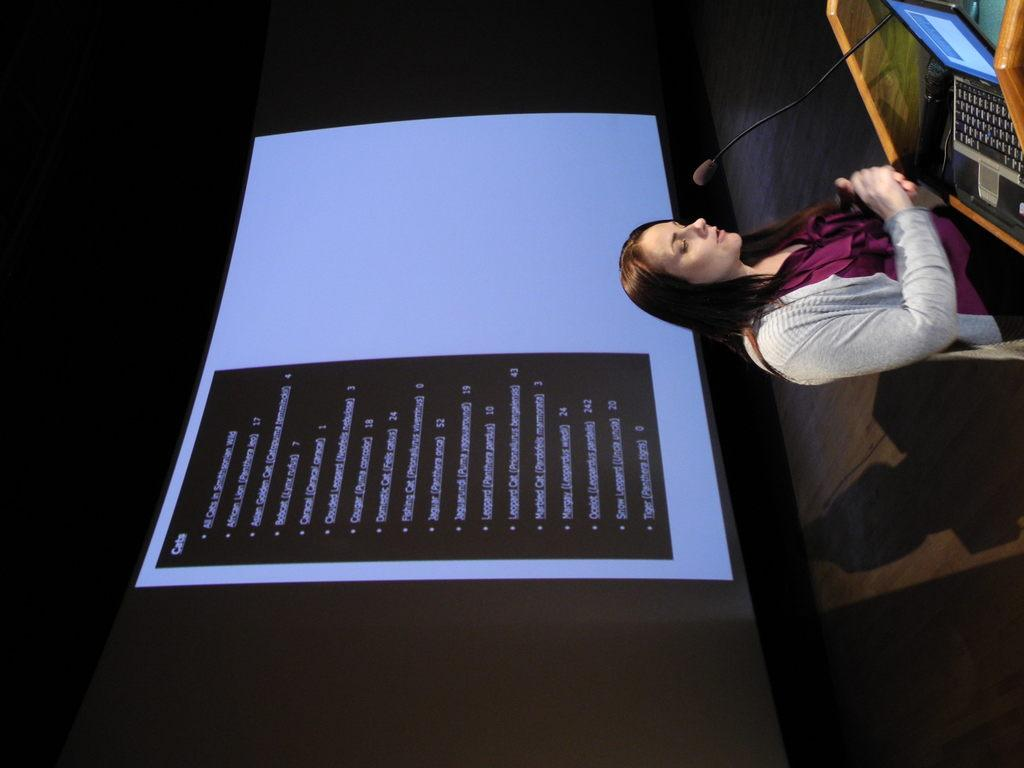Who is the main subject in the image? There is a lady in the image. What is the lady standing in front of? The lady is in front of a podium. What items are on the podium? There is a microphone and a laptop on the podium. What can be seen in the background of the image? There is a screen in the background of the image. What is the tax rate for the volleyball game being discussed on the screen in the image? There is no mention of a volleyball game or tax rate in the image. The screen in the background may display information related to the lady's presentation, but it is not visible in the image. 